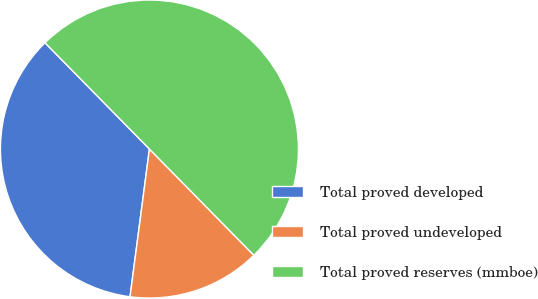Convert chart to OTSL. <chart><loc_0><loc_0><loc_500><loc_500><pie_chart><fcel>Total proved developed<fcel>Total proved undeveloped<fcel>Total proved reserves (mmboe)<nl><fcel>35.56%<fcel>14.44%<fcel>50.0%<nl></chart> 